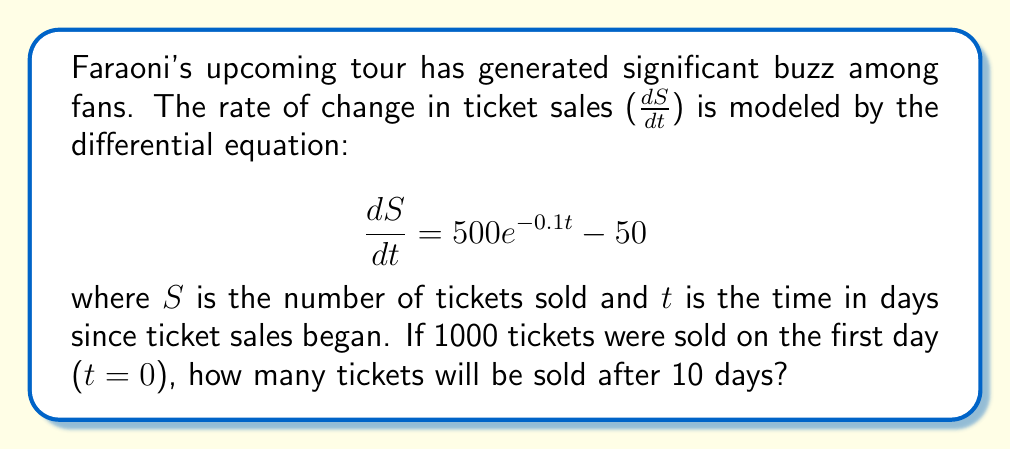What is the answer to this math problem? To solve this problem, we need to follow these steps:

1) First, we need to solve the differential equation. The general solution is:

   $$S = \int (500e^{-0.1t} - 50) dt$$

2) Integrating both sides:

   $$S = -5000e^{-0.1t} - 50t + C$$

   where C is the constant of integration.

3) We can find C using the initial condition: S(0) = 1000

   $$1000 = -5000e^{-0.1(0)} - 50(0) + C$$
   $$1000 = -5000 + C$$
   $$C = 6000$$

4) So, the particular solution is:

   $$S = -5000e^{-0.1t} - 50t + 6000$$

5) To find the number of tickets sold after 10 days, we substitute t = 10:

   $$S(10) = -5000e^{-0.1(10)} - 50(10) + 6000$$
   $$S(10) = -5000e^{-1} - 500 + 6000$$
   $$S(10) = -1839.40 - 500 + 6000$$
   $$S(10) = 3660.60$$

6) Rounding to the nearest whole number (as we can't sell partial tickets):

   S(10) ≈ 3661 tickets
Answer: After 10 days, approximately 3661 tickets will be sold for Faraoni's upcoming tour. 